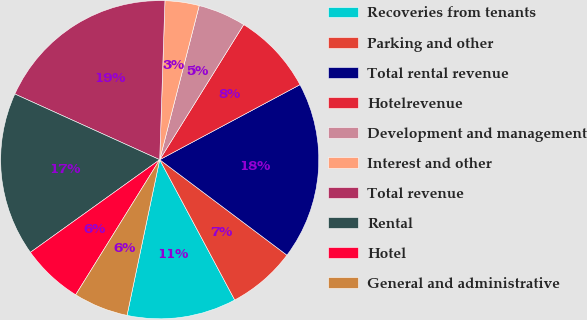Convert chart to OTSL. <chart><loc_0><loc_0><loc_500><loc_500><pie_chart><fcel>Recoveries from tenants<fcel>Parking and other<fcel>Total rental revenue<fcel>Hotelrevenue<fcel>Development and management<fcel>Interest and other<fcel>Total revenue<fcel>Rental<fcel>Hotel<fcel>General and administrative<nl><fcel>11.11%<fcel>6.94%<fcel>18.06%<fcel>8.33%<fcel>4.86%<fcel>3.47%<fcel>18.75%<fcel>16.67%<fcel>6.25%<fcel>5.56%<nl></chart> 